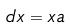<formula> <loc_0><loc_0><loc_500><loc_500>d x = x a</formula> 